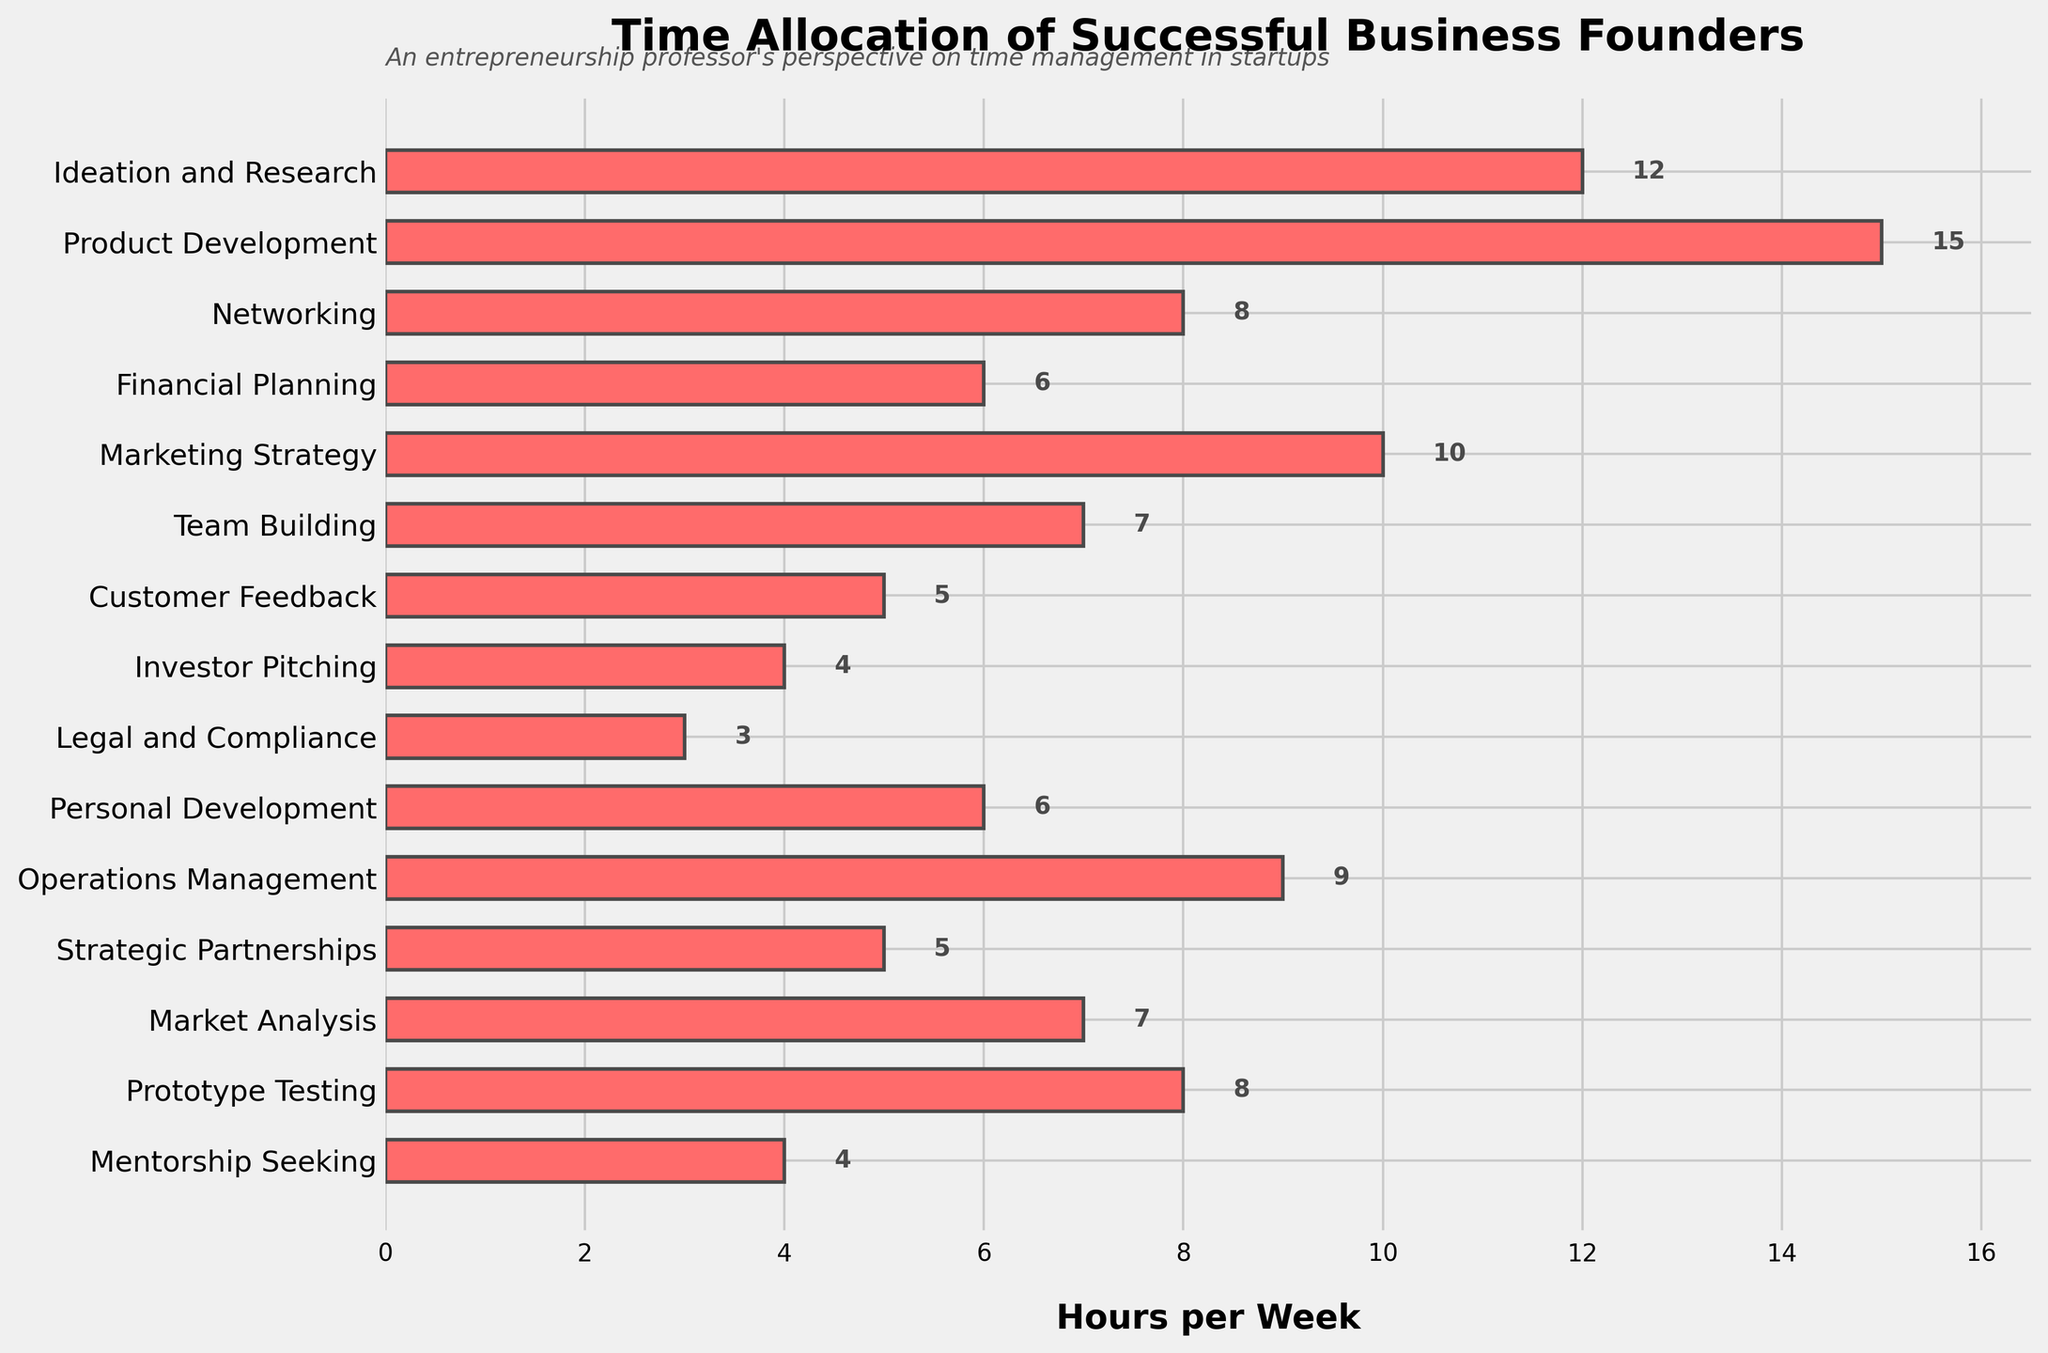What activity do successful business founders spend the most time on per week? The tallest bar in the horizontal bar chart represents the activity with the most hours spent per week. Here, the "Product Development" bar is the tallest.
Answer: Product Development Which activities are allocated exactly 6 hours per week? Identify the bars in the chart that have their labels or lengths corresponding to the value 6. "Financial Planning" and "Personal Development" both have bars labeled 6.
Answer: Financial Planning, Personal Development What's the total time spent on "Networking" and "Market Analysis" combined? Find the bars for "Networking" and "Market Analysis" and add their corresponding hours. Networking (8) + Market Analysis (7) = 15 hours.
Answer: 15 hours How many more hours are spent on "Product Development" than on "Investor Pitching"? Subtract the hours allocated to "Investor Pitching" from "Product Development". Product Development (15) - Investor Pitching (4) = 11 hours.
Answer: 11 hours Which activity is allocated the least amount of time per week? The shortest bar in the chart represents the activity with the least hours spent per week. The "Legal and Compliance" bar is the shortest.
Answer: Legal and Compliance How does the time spent on "Marketing Strategy" compare to "Operations Management"? Compare the bars' lengths or labels for "Marketing Strategy" and "Operations Management". Marketing Strategy (10) vs Operations Management (9). Marketing Strategy involves 1 more hour.
Answer: Marketing Strategy > Operations Management What's the sum of hours spent on "Team Building," "Customer Feedback," and "Mentorship Seeking"? Look at the hours for each activity and add them together. Team Building (7) + Customer Feedback (5) + Mentorship Seeking (4) = 16 hours.
Answer: 16 hours What's the average time spent on "Strategic Partnerships", "Prototype Testing," and "Mentorship Seeking"? Add the hours of these activities and then divide by the number of activities. (5 + 8 + 4) / 3 = 5.67 hours.
Answer: 5.67 hours Compare the time spent on "Ideation and Research" to the sum of "Investor Pitching" and "Legal and Compliance". Calculate the sum of hours for "Investor Pitching" and "Legal and Compliance" and compare it to "Ideation and Research". Investor Pitching (4) + Legal and Compliance (3) = 7 hours; Ideation and Research is 12 hours.
Answer: Ideation and Research > Investor Pitching + Legal and Compliance Which activities are allocated more than 10 hours per week? Identify the bars that extend beyond the 10-hour mark. "Ideation and Research" (12) and "Product Development" (15) are the only activities allocated more than 10 hours per week.
Answer: Ideation and Research, Product Development 